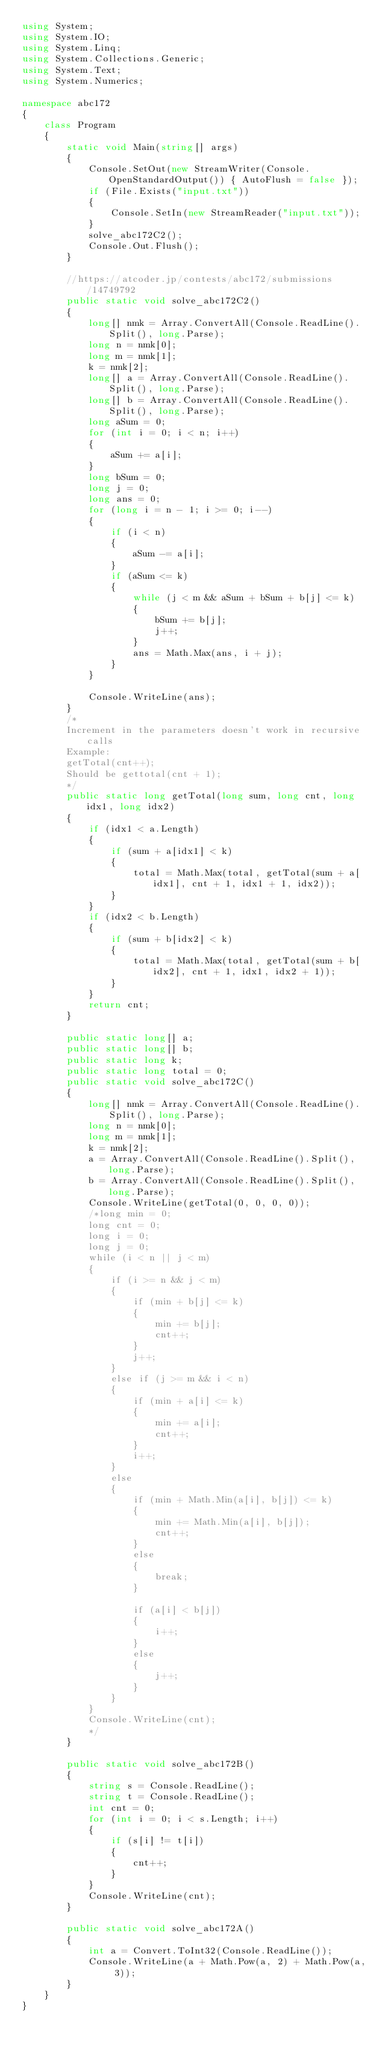<code> <loc_0><loc_0><loc_500><loc_500><_C#_>using System;
using System.IO;
using System.Linq;
using System.Collections.Generic;
using System.Text;
using System.Numerics;

namespace abc172
{
    class Program
    {
        static void Main(string[] args)
        {
            Console.SetOut(new StreamWriter(Console.OpenStandardOutput()) { AutoFlush = false });
            if (File.Exists("input.txt"))
            {
                Console.SetIn(new StreamReader("input.txt"));
            }
            solve_abc172C2();
            Console.Out.Flush();
        }

        //https://atcoder.jp/contests/abc172/submissions/14749792
        public static void solve_abc172C2()
        {
            long[] nmk = Array.ConvertAll(Console.ReadLine().Split(), long.Parse);
            long n = nmk[0];
            long m = nmk[1];
            k = nmk[2];
            long[] a = Array.ConvertAll(Console.ReadLine().Split(), long.Parse);
            long[] b = Array.ConvertAll(Console.ReadLine().Split(), long.Parse);
            long aSum = 0;
            for (int i = 0; i < n; i++)
            {
                aSum += a[i];
            }
            long bSum = 0;
            long j = 0;
            long ans = 0;
            for (long i = n - 1; i >= 0; i--)
            {
                if (i < n)
                {
                    aSum -= a[i];
                }
                if (aSum <= k)
                {
                    while (j < m && aSum + bSum + b[j] <= k)
                    {
                        bSum += b[j];
                        j++;
                    }
                    ans = Math.Max(ans, i + j);
                }
            }

            Console.WriteLine(ans);
        }
        /*
        Increment in the parameters doesn't work in recursive calls
        Example:
        getTotal(cnt++);
        Should be gettotal(cnt + 1);
        */
        public static long getTotal(long sum, long cnt, long idx1, long idx2)
        {
            if (idx1 < a.Length)
            {
                if (sum + a[idx1] < k)
                {
                    total = Math.Max(total, getTotal(sum + a[idx1], cnt + 1, idx1 + 1, idx2));
                }
            }
            if (idx2 < b.Length)
            {
                if (sum + b[idx2] < k)
                {
                    total = Math.Max(total, getTotal(sum + b[idx2], cnt + 1, idx1, idx2 + 1));
                }
            }
            return cnt;
        }

        public static long[] a;
        public static long[] b;
        public static long k;
        public static long total = 0;
        public static void solve_abc172C()
        {
            long[] nmk = Array.ConvertAll(Console.ReadLine().Split(), long.Parse);
            long n = nmk[0];
            long m = nmk[1];
            k = nmk[2];
            a = Array.ConvertAll(Console.ReadLine().Split(), long.Parse);
            b = Array.ConvertAll(Console.ReadLine().Split(), long.Parse);
            Console.WriteLine(getTotal(0, 0, 0, 0));
            /*long min = 0;
            long cnt = 0;
            long i = 0;
            long j = 0;
            while (i < n || j < m)
            {
                if (i >= n && j < m)
                {
                    if (min + b[j] <= k)
                    {
                        min += b[j];
                        cnt++;
                    }
                    j++;
                }
                else if (j >= m && i < n)
                {
                    if (min + a[i] <= k)
                    {
                        min += a[i];
                        cnt++;
                    }
                    i++;
                }
                else
                {
                    if (min + Math.Min(a[i], b[j]) <= k)
                    {
                        min += Math.Min(a[i], b[j]);
                        cnt++;
                    }
                    else
                    {
                        break;
                    }  

                    if (a[i] < b[j])
                    {
                        i++;
                    }
                    else
                    {
                        j++;
                    }
                }
            }
            Console.WriteLine(cnt);
            */
        }

        public static void solve_abc172B()
        {
            string s = Console.ReadLine();
            string t = Console.ReadLine();
            int cnt = 0;
            for (int i = 0; i < s.Length; i++)
            {
                if (s[i] != t[i])
                {
                    cnt++;
                }
            }
            Console.WriteLine(cnt);
        }

        public static void solve_abc172A()
        {
            int a = Convert.ToInt32(Console.ReadLine());
            Console.WriteLine(a + Math.Pow(a, 2) + Math.Pow(a, 3));
        }
    }
}</code> 